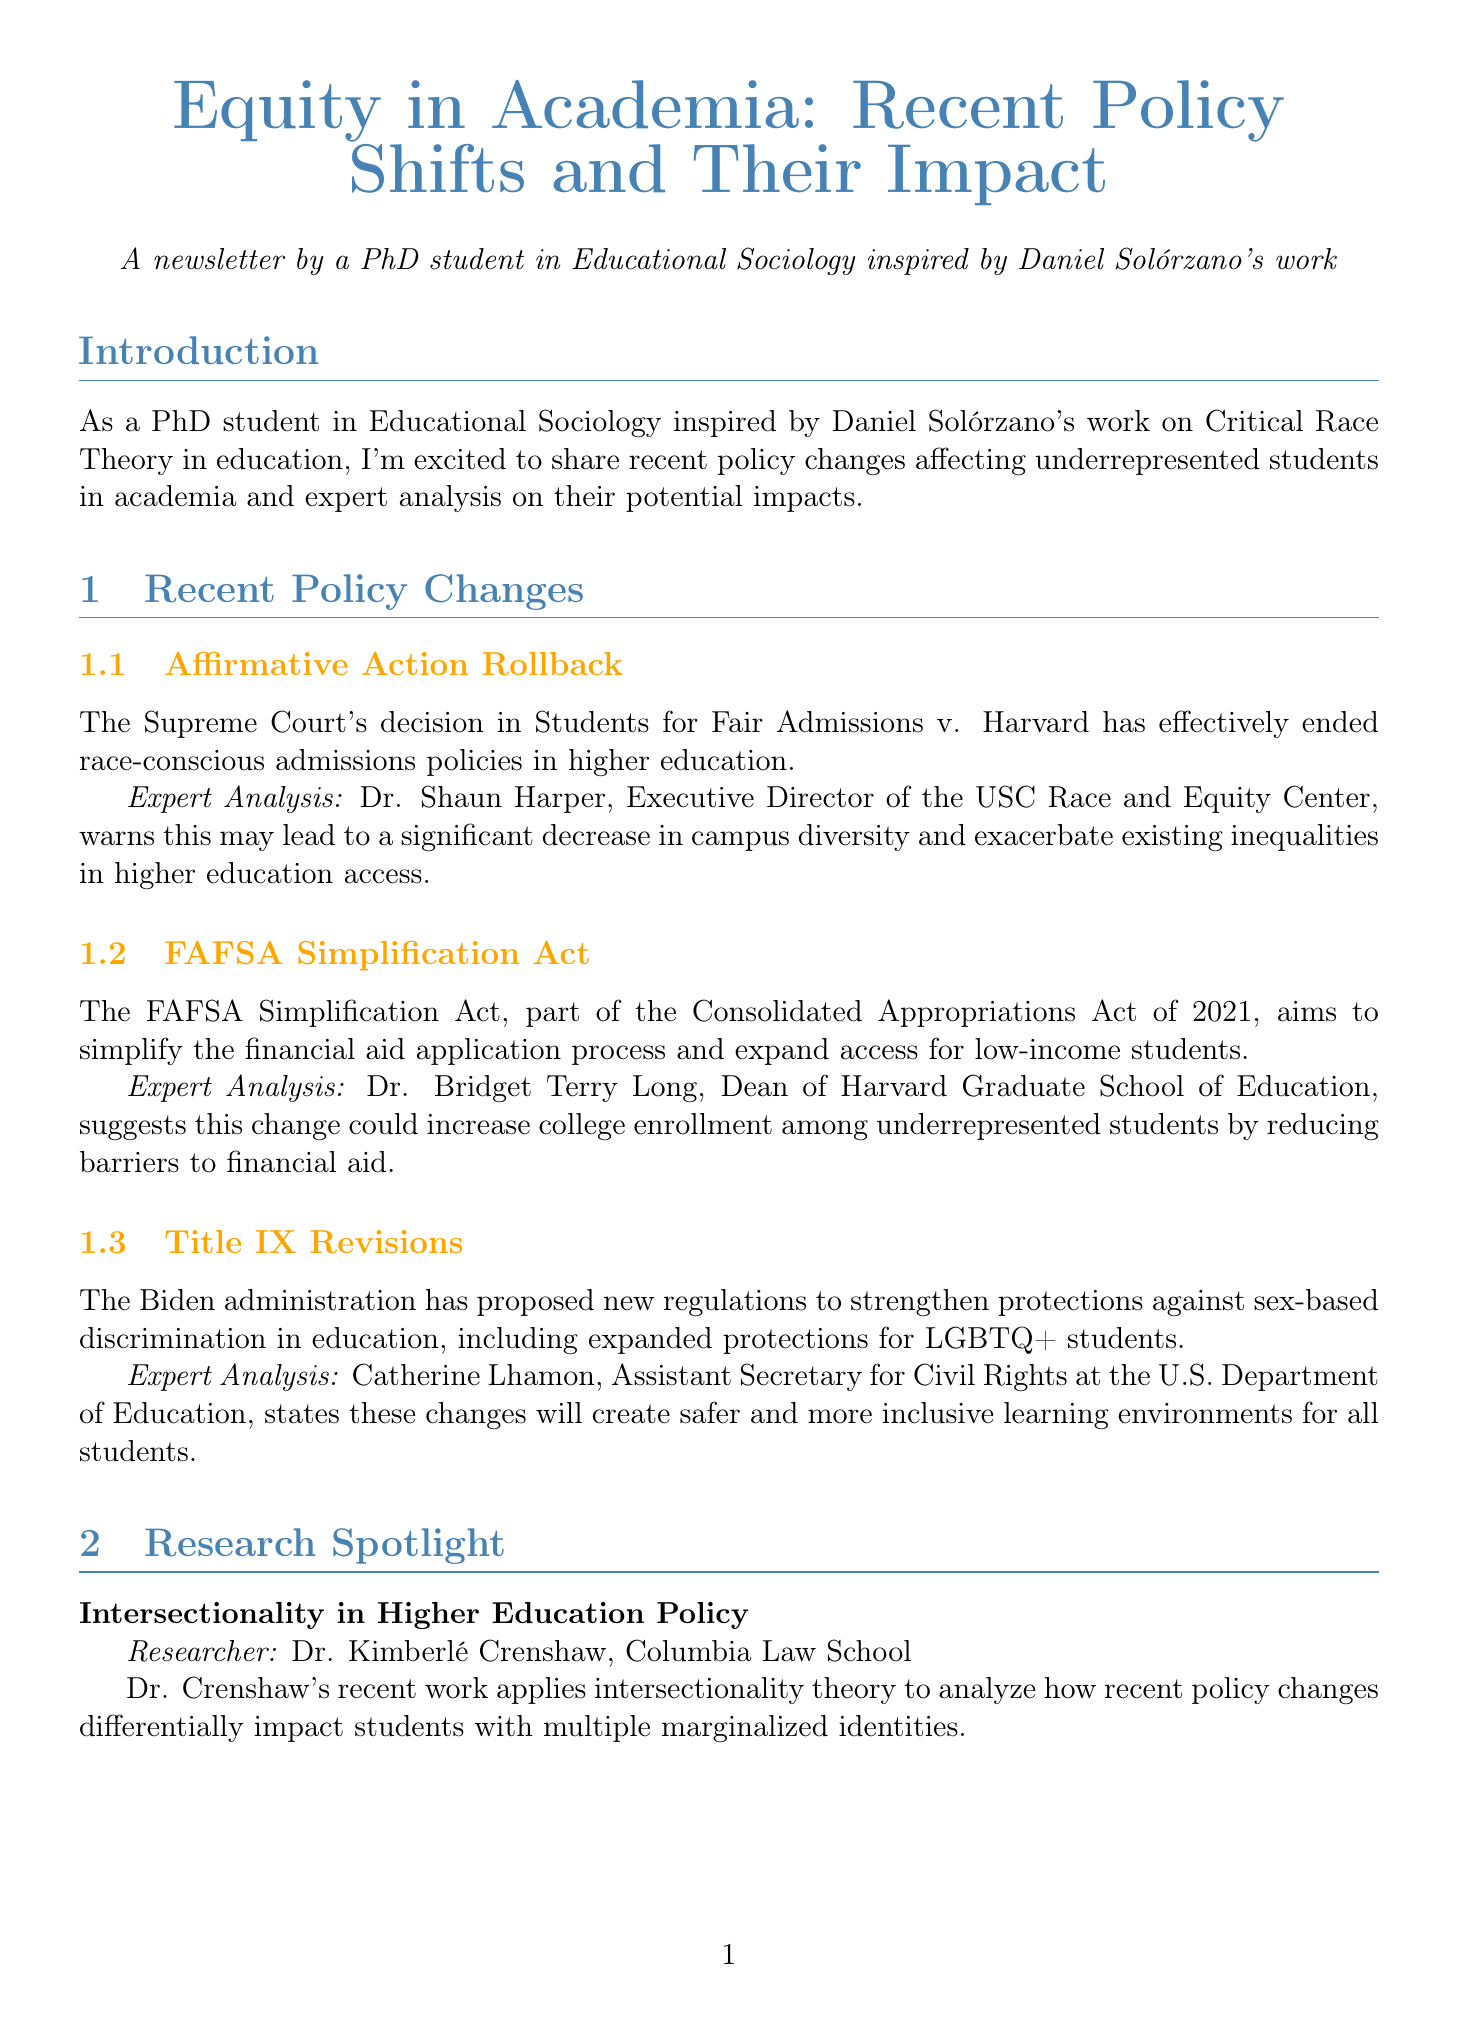what is the title of the newsletter? The title of the newsletter provides the main topic and is stated clearly at the beginning of the document.
Answer: Equity in Academia: Recent Policy Shifts and Their Impact who authored the expert analysis on the FAFSA Simplification Act? The document names the individual providing the expert analysis for each policy change.
Answer: Dr. Bridget Terry Long what is the date of the ASHE conference? The document includes specific dates for upcoming events, which helps in planning and attendance.
Answer: November 15-18, 2023 which institution launched the HSI Task Force? The document lists initiatives taken by various universities, indicating proactive measures in response to policy changes.
Answer: University of California, Berkeley how does Dr. Shaun Harper view the impact of the Affirmative Action rollback? The expert analysis section contains insights from experts regarding the implications of policy changes.
Answer: Decrease in campus diversity what theme will the ASHE conference focus on? The document specifies themes for upcoming events, providing context for the discussions that will take place.
Answer: Centering Justice and Equity in Turbulent Times who is the researcher featured in the research spotlight section? This question retrieves information about the individual highlighted for their work related to the newsletter's topic.
Answer: Dr. Kimberlé Crenshaw what initiative is Howard University part of? The document states specific initiatives and their goals, reflecting institutional efforts to support underrepresented students.
Answer: HBCUs STEM Success Initiative what new regulations were proposed by the Biden administration? The document outlines significant policy changes and their intentions in education, crucial for understanding the current landscape.
Answer: Title IX Revisions 